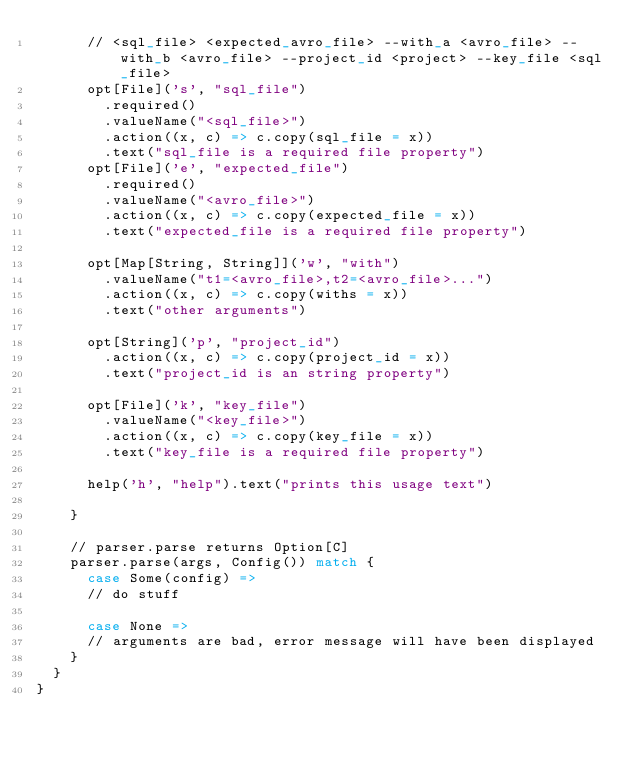<code> <loc_0><loc_0><loc_500><loc_500><_Scala_>      // <sql_file> <expected_avro_file> --with_a <avro_file> --with_b <avro_file> --project_id <project> --key_file <sql_file>
      opt[File]('s', "sql_file")
        .required()
        .valueName("<sql_file>")
        .action((x, c) => c.copy(sql_file = x))
        .text("sql_file is a required file property")
      opt[File]('e', "expected_file")
        .required()
        .valueName("<avro_file>")
        .action((x, c) => c.copy(expected_file = x))
        .text("expected_file is a required file property")

      opt[Map[String, String]]('w', "with")
        .valueName("t1=<avro_file>,t2=<avro_file>...")
        .action((x, c) => c.copy(withs = x))
        .text("other arguments")

      opt[String]('p', "project_id")
        .action((x, c) => c.copy(project_id = x))
        .text("project_id is an string property")

      opt[File]('k', "key_file")
        .valueName("<key_file>")
        .action((x, c) => c.copy(key_file = x))
        .text("key_file is a required file property")

      help('h', "help").text("prints this usage text")

    }

    // parser.parse returns Option[C]
    parser.parse(args, Config()) match {
      case Some(config) =>
      // do stuff

      case None =>
      // arguments are bad, error message will have been displayed
    }
  }
}
</code> 